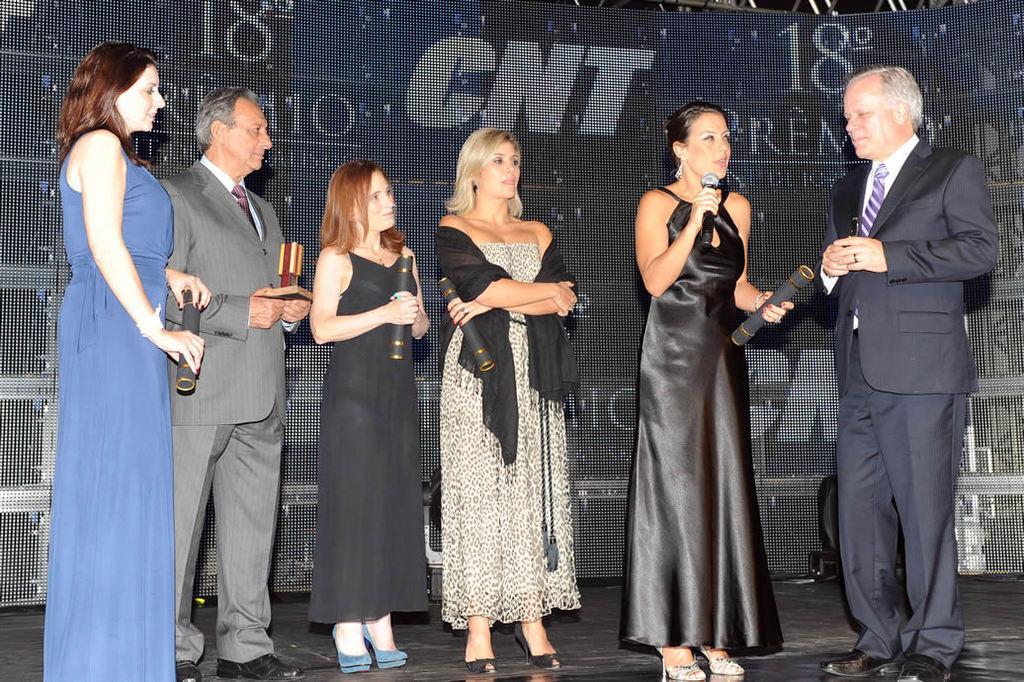In one or two sentences, can you explain what this image depicts? On the left side of the image we can see two persons are standing and holding something in their hands. In the middle of the image we can see two ladies are standing and holding something in their hands and a digital screen is displayed back of them. On the right side of the image we can see two persons are standing and a lady is holding a mike and asking something to the opposite person. 